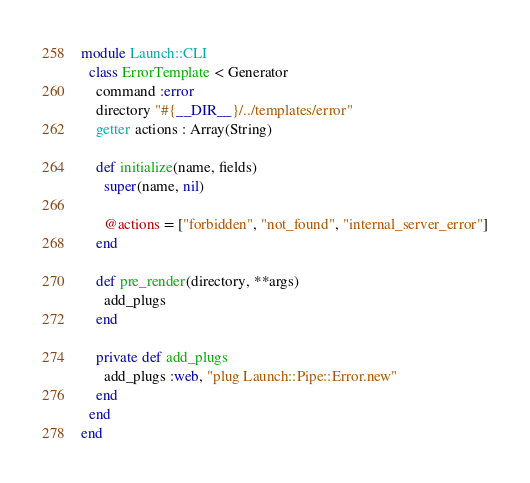<code> <loc_0><loc_0><loc_500><loc_500><_Crystal_>module Launch::CLI
  class ErrorTemplate < Generator
    command :error
    directory "#{__DIR__}/../templates/error"
    getter actions : Array(String)

    def initialize(name, fields)
      super(name, nil)

      @actions = ["forbidden", "not_found", "internal_server_error"]
    end

    def pre_render(directory, **args)
      add_plugs
    end

    private def add_plugs
      add_plugs :web, "plug Launch::Pipe::Error.new"
    end
  end
end
</code> 